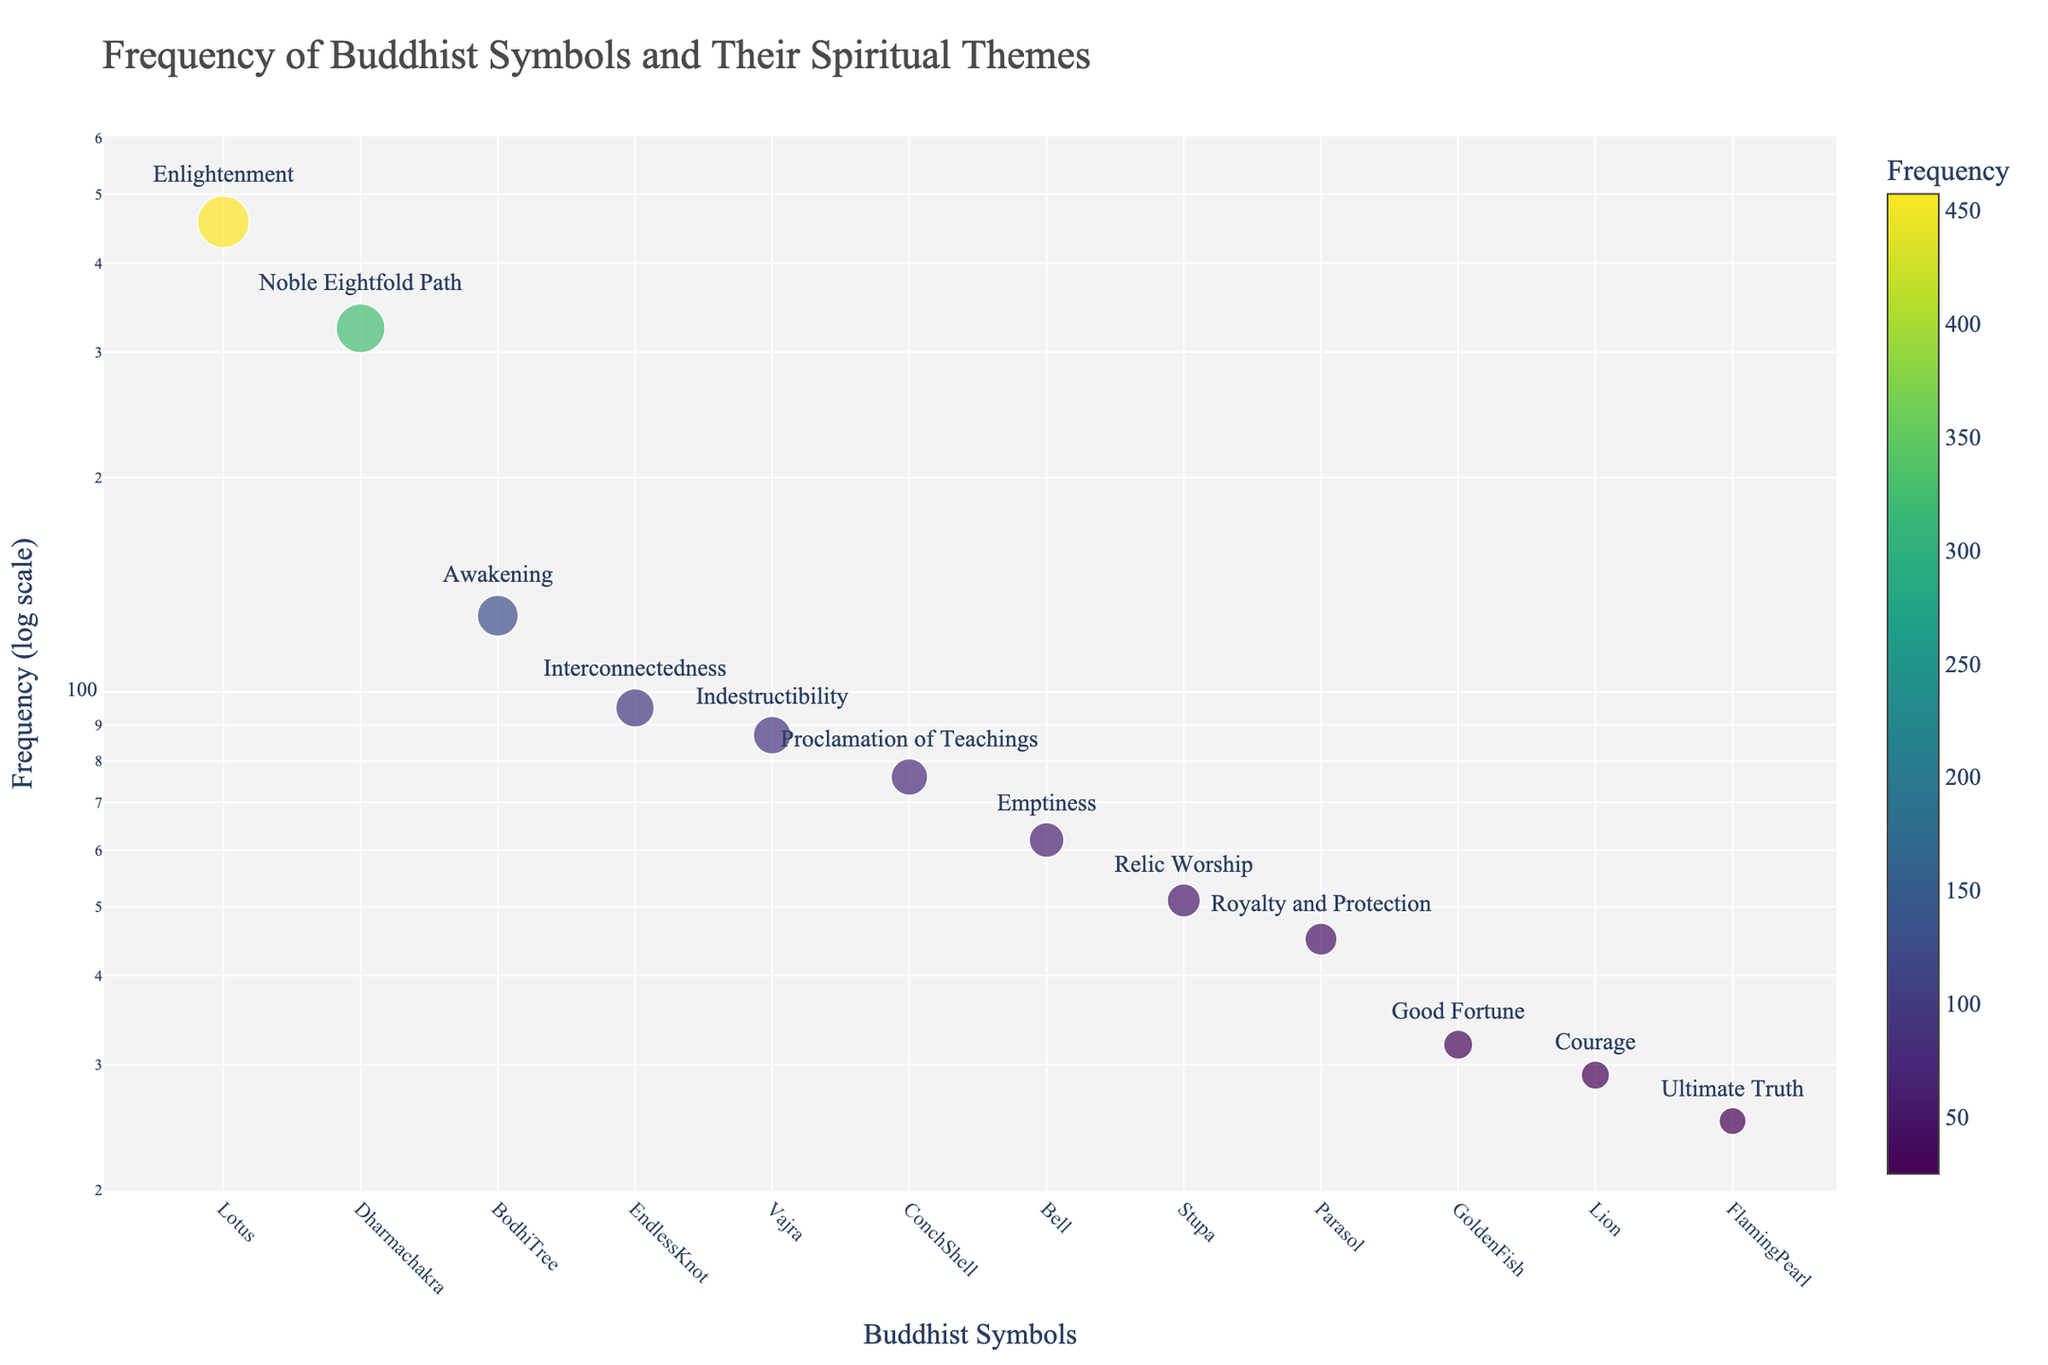What's the title of the figure? The title of the figure is often located at the top, and in this case, it clearly states the purpose and content of the graph.
Answer: Frequency of Buddhist Symbols and Their Spiritual Themes What symbol appears most frequently in the dataset? The most frequent symbol can be identified as the highest point on the vertical (logarithmic) axis. The symbol with the highest y-axis value is 'Lotus'.
Answer: Lotus Which symbol has the lowest frequency, and what spiritual theme does it represent? The lowest frequency is indicated by the smallest y-axis value. By observing the figure, the symbol with the lowest frequency is 'Flaming Pearl', representing 'Ultimate Truth'.
Answer: Flaming Pearl, Ultimate Truth How does the frequency of the Dharmachakra compare to the Vajra? To compare the two symbols, look at their respective y-axis values. The Dharmachakra has a higher frequency (324) compared to the Vajra (87).
Answer: Dharmachakra has a higher frequency than Vajra What is the range of frequencies covered in the figure? Identify the maximum and minimum frequencies from the graph. The highest value is for the Lotus (457) and the lowest is for the Flaming Pearl (25). The range is 457 - 25.
Answer: 432 What symbols have a frequency between 50 and 100, and what themes do they represent? Look for symbols with y-axis values between 50 and 100. The symbols in this range are 'Endless Knot' (95, Interconnectedness), 'Vajra' (87, Indestructibility), 'Bell' (62, Emptiness), and 'Stupa' (51, Relic Worship).
Answer: Endless Knot, Vajra, Bell, Stupa What is the frequency of the Bodhi Tree, and what spiritual theme does it relate to? Identify the specific point for 'Bodhi Tree' on the graph and note its y-axis value and corresponding theme. The Bodhi Tree has a frequency of 128 and represents 'Awakening'.
Answer: 128, Awakening How does the theme of 'Good Fortune' relate to the frequency of its associated symbol? Locate the symbol associated with 'Good Fortune' and find its y-axis value. The 'Golden Fish' represents 'Good Fortune' with a frequency of 32.
Answer: Golden Fish, 32 What spiritual theme is represented by symbols with a frequency of less than 30? Locate symbols with frequencies below 30 and identify their themes. 'Lion' (29, Courage) and 'Flaming Pearl' (25, Ultimate Truth).
Answer: Courage, Ultimate Truth Why is the log scale axis used for frequency in this figure? A logarithmic scale is used when data spans several orders of magnitude. Here, the frequency of symbols ranges greatly, from 25 to 457. Using a log scale allows for better visualization and comparison of symbols with smaller and larger frequencies on the same plot.
Answer: To better visualize data with a wide range of frequencies 